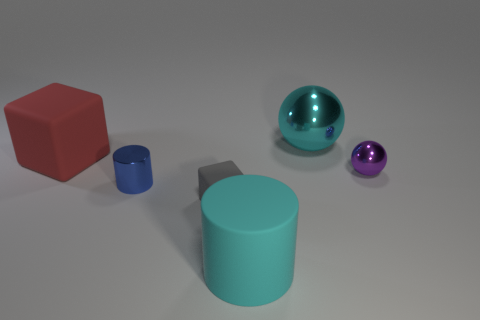Add 2 yellow cylinders. How many objects exist? 8 Subtract all purple balls. How many balls are left? 1 Subtract all yellow cubes. How many purple spheres are left? 1 Subtract 0 brown cylinders. How many objects are left? 6 Subtract all cylinders. How many objects are left? 4 Subtract 1 spheres. How many spheres are left? 1 Subtract all brown blocks. Subtract all blue balls. How many blocks are left? 2 Subtract all gray blocks. Subtract all red cubes. How many objects are left? 4 Add 1 purple balls. How many purple balls are left? 2 Add 5 large red matte objects. How many large red matte objects exist? 6 